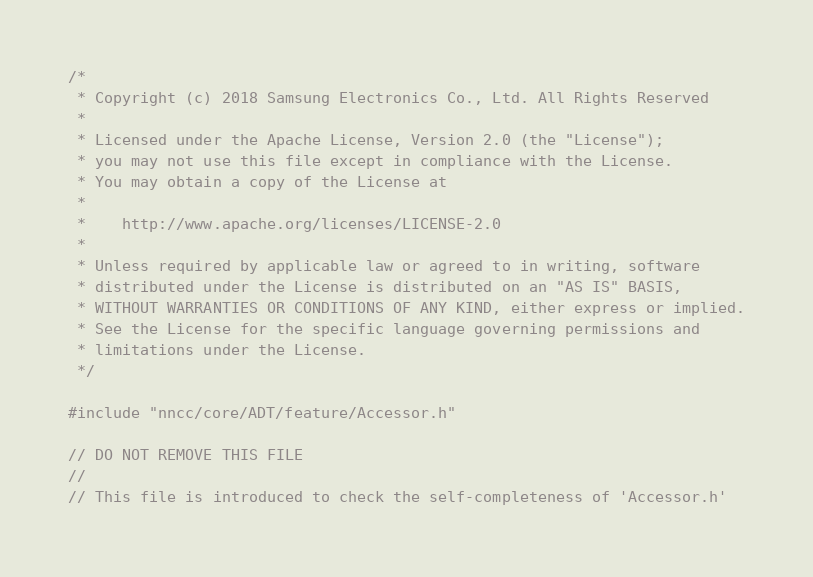Convert code to text. <code><loc_0><loc_0><loc_500><loc_500><_C++_>/*
 * Copyright (c) 2018 Samsung Electronics Co., Ltd. All Rights Reserved
 *
 * Licensed under the Apache License, Version 2.0 (the "License");
 * you may not use this file except in compliance with the License.
 * You may obtain a copy of the License at
 *
 *    http://www.apache.org/licenses/LICENSE-2.0
 *
 * Unless required by applicable law or agreed to in writing, software
 * distributed under the License is distributed on an "AS IS" BASIS,
 * WITHOUT WARRANTIES OR CONDITIONS OF ANY KIND, either express or implied.
 * See the License for the specific language governing permissions and
 * limitations under the License.
 */

#include "nncc/core/ADT/feature/Accessor.h"

// DO NOT REMOVE THIS FILE
//
// This file is introduced to check the self-completeness of 'Accessor.h'
</code> 